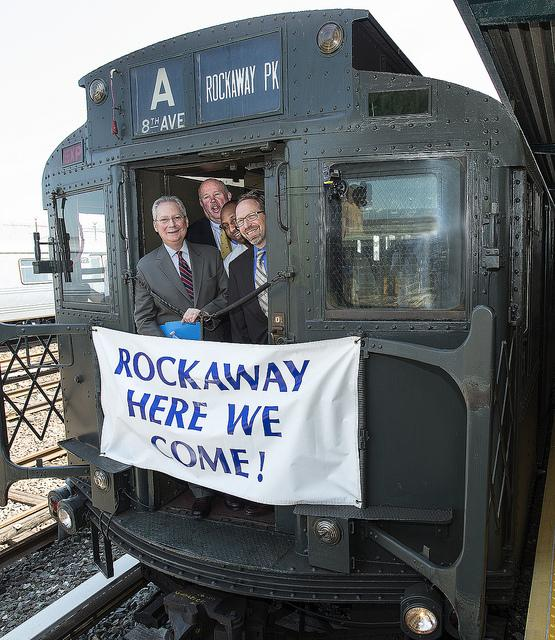Where is this train heading? Please explain your reasoning. rockaway. There is a sign saying they are on their way to rockaway on the back of the train. 